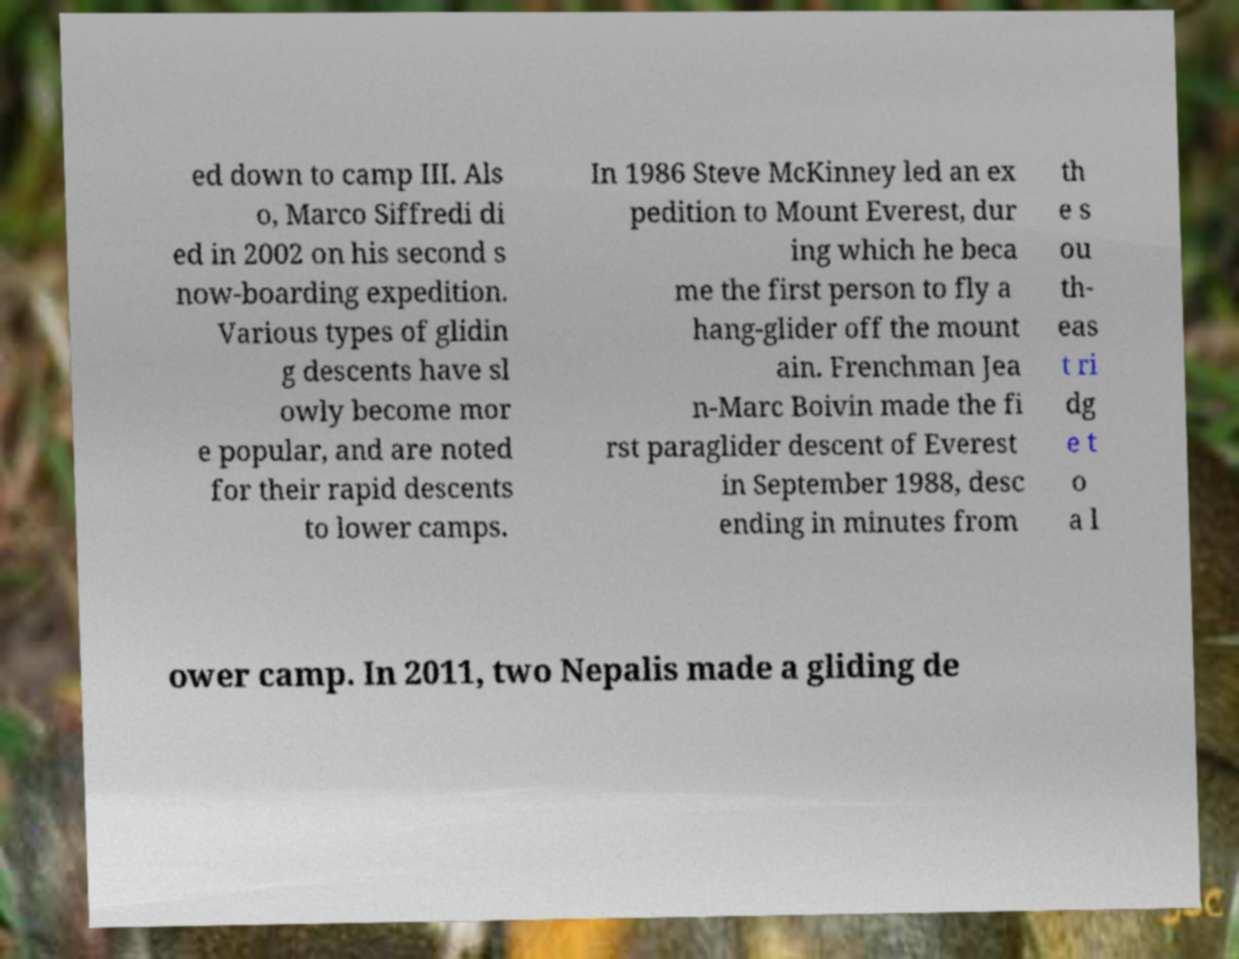Please identify and transcribe the text found in this image. ed down to camp III. Als o, Marco Siffredi di ed in 2002 on his second s now-boarding expedition. Various types of glidin g descents have sl owly become mor e popular, and are noted for their rapid descents to lower camps. In 1986 Steve McKinney led an ex pedition to Mount Everest, dur ing which he beca me the first person to fly a hang-glider off the mount ain. Frenchman Jea n-Marc Boivin made the fi rst paraglider descent of Everest in September 1988, desc ending in minutes from th e s ou th- eas t ri dg e t o a l ower camp. In 2011, two Nepalis made a gliding de 